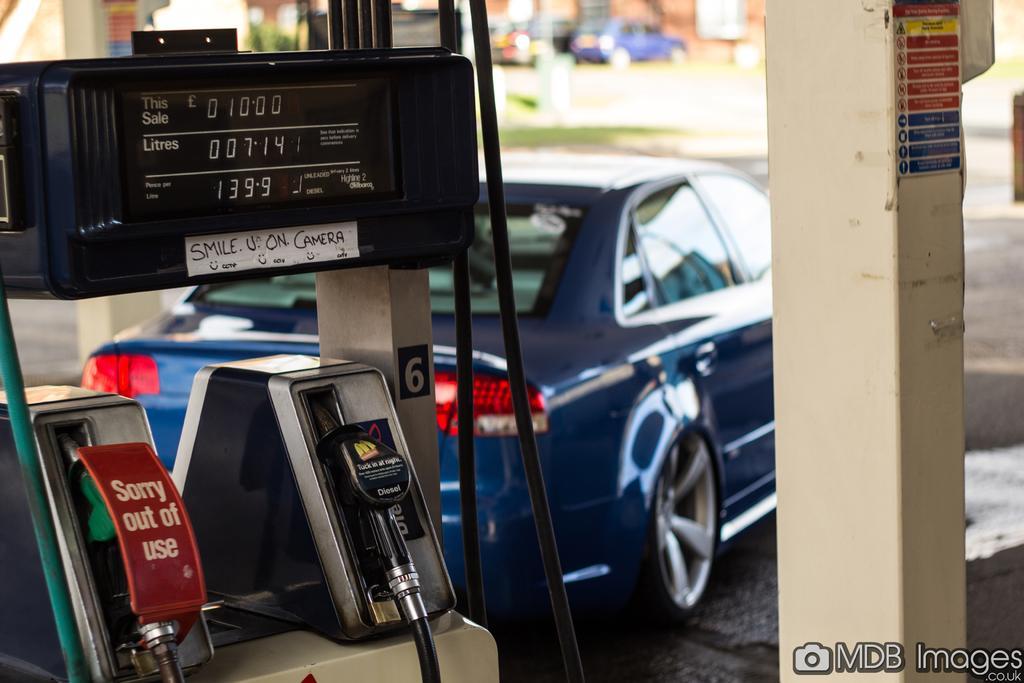In one or two sentences, can you explain what this image depicts? In the foreground of this image, there is a fuel dispensing machine. On the right, there is a pillar and a water mark at the bottom. In the background, there is a car on the ground and the top side of the image is blur. 